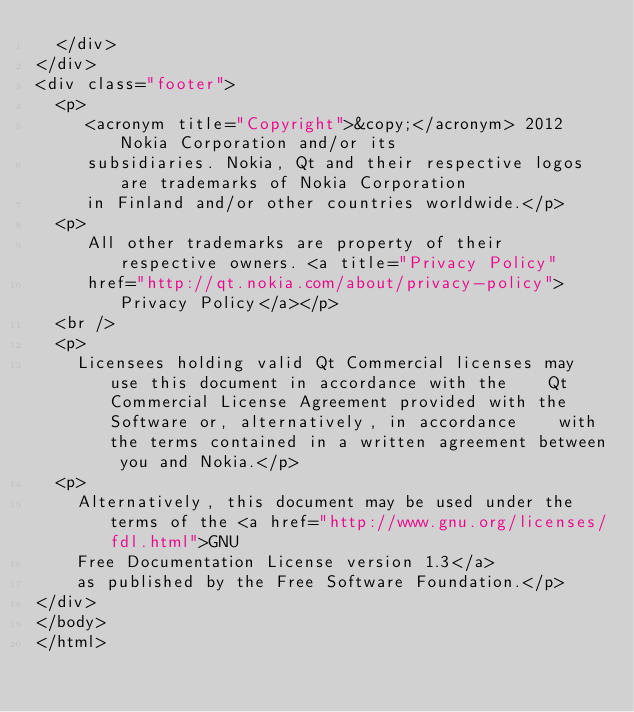<code> <loc_0><loc_0><loc_500><loc_500><_HTML_>  </div>
</div> 
<div class="footer">
  <p>
     <acronym title="Copyright">&copy;</acronym> 2012 Nokia Corporation and/or its
     subsidiaries. Nokia, Qt and their respective logos are trademarks of Nokia Corporation 
     in Finland and/or other countries worldwide.</p>
  <p>
     All other trademarks are property of their respective owners. <a title="Privacy Policy"
     href="http://qt.nokia.com/about/privacy-policy">Privacy Policy</a></p>
  <br />
  <p>
    Licensees holding valid Qt Commercial licenses may use this document in accordance with the    Qt Commercial License Agreement provided with the Software or, alternatively, in accordance    with the terms contained in a written agreement between you and Nokia.</p>
  <p>
    Alternatively, this document may be used under the terms of the <a href="http://www.gnu.org/licenses/fdl.html">GNU
    Free Documentation License version 1.3</a>
    as published by the Free Software Foundation.</p>
</div>
</body>
</html>
</code> 